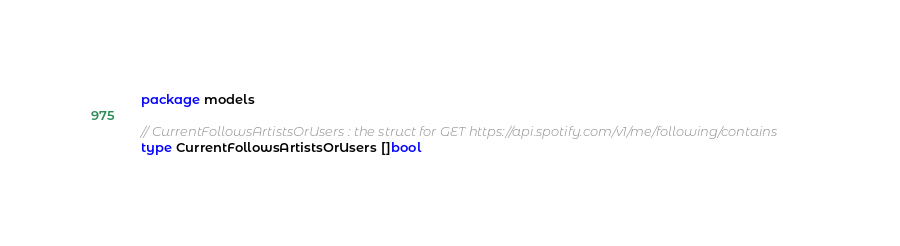<code> <loc_0><loc_0><loc_500><loc_500><_Go_>package models

// CurrentFollowsArtistsOrUsers : the struct for GET https://api.spotify.com/v1/me/following/contains
type CurrentFollowsArtistsOrUsers []bool
</code> 